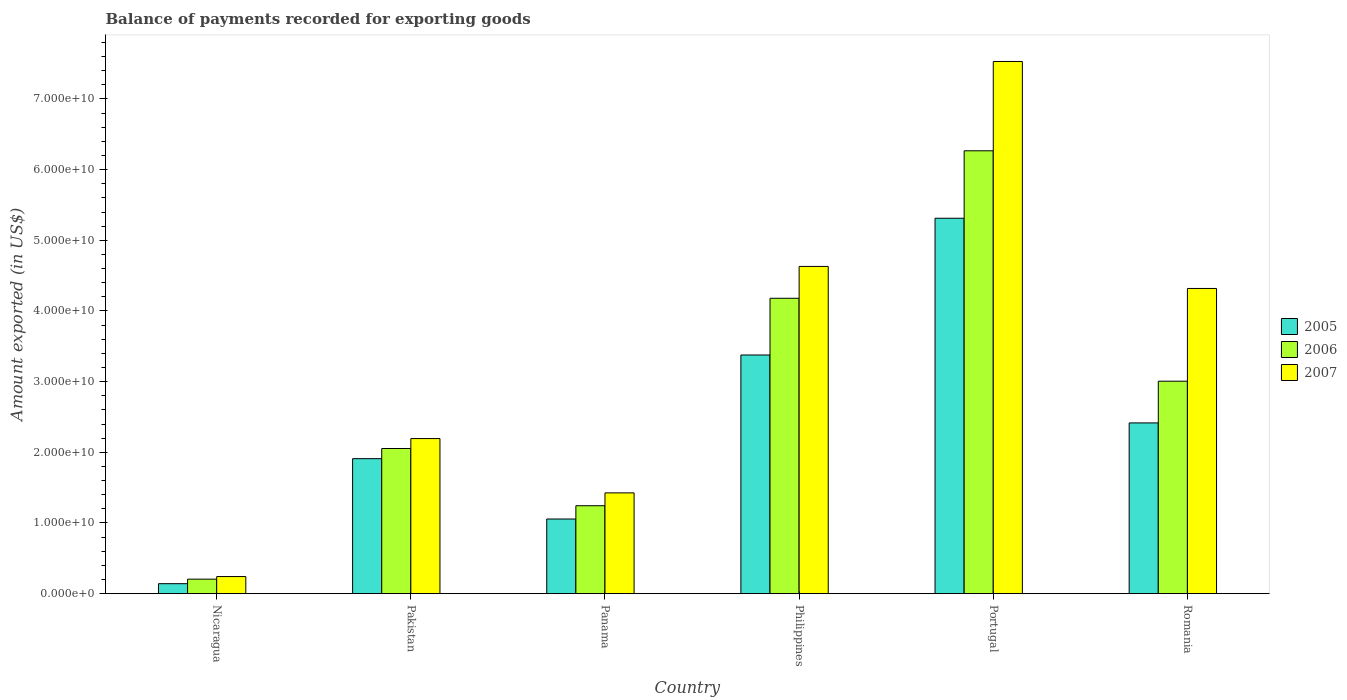How many different coloured bars are there?
Provide a succinct answer. 3. How many groups of bars are there?
Your answer should be very brief. 6. Are the number of bars per tick equal to the number of legend labels?
Provide a succinct answer. Yes. How many bars are there on the 4th tick from the left?
Your answer should be very brief. 3. How many bars are there on the 5th tick from the right?
Provide a succinct answer. 3. What is the label of the 2nd group of bars from the left?
Make the answer very short. Pakistan. In how many cases, is the number of bars for a given country not equal to the number of legend labels?
Your response must be concise. 0. What is the amount exported in 2005 in Pakistan?
Give a very brief answer. 1.91e+1. Across all countries, what is the maximum amount exported in 2005?
Your response must be concise. 5.31e+1. Across all countries, what is the minimum amount exported in 2005?
Your answer should be compact. 1.41e+09. In which country was the amount exported in 2007 minimum?
Your response must be concise. Nicaragua. What is the total amount exported in 2006 in the graph?
Give a very brief answer. 1.70e+11. What is the difference between the amount exported in 2005 in Portugal and that in Romania?
Your response must be concise. 2.90e+1. What is the difference between the amount exported in 2006 in Romania and the amount exported in 2005 in Nicaragua?
Keep it short and to the point. 2.87e+1. What is the average amount exported in 2006 per country?
Offer a terse response. 2.83e+1. What is the difference between the amount exported of/in 2007 and amount exported of/in 2006 in Portugal?
Your answer should be very brief. 1.26e+1. What is the ratio of the amount exported in 2005 in Panama to that in Portugal?
Ensure brevity in your answer.  0.2. Is the amount exported in 2006 in Pakistan less than that in Panama?
Provide a short and direct response. No. Is the difference between the amount exported in 2007 in Portugal and Romania greater than the difference between the amount exported in 2006 in Portugal and Romania?
Your response must be concise. No. What is the difference between the highest and the second highest amount exported in 2006?
Offer a terse response. 1.17e+1. What is the difference between the highest and the lowest amount exported in 2005?
Make the answer very short. 5.17e+1. In how many countries, is the amount exported in 2006 greater than the average amount exported in 2006 taken over all countries?
Give a very brief answer. 3. Is the sum of the amount exported in 2006 in Philippines and Romania greater than the maximum amount exported in 2005 across all countries?
Ensure brevity in your answer.  Yes. What does the 3rd bar from the right in Nicaragua represents?
Offer a very short reply. 2005. Is it the case that in every country, the sum of the amount exported in 2006 and amount exported in 2005 is greater than the amount exported in 2007?
Your response must be concise. Yes. How many countries are there in the graph?
Keep it short and to the point. 6. What is the difference between two consecutive major ticks on the Y-axis?
Your answer should be compact. 1.00e+1. Does the graph contain grids?
Provide a short and direct response. No. Where does the legend appear in the graph?
Your answer should be very brief. Center right. How many legend labels are there?
Ensure brevity in your answer.  3. What is the title of the graph?
Keep it short and to the point. Balance of payments recorded for exporting goods. What is the label or title of the X-axis?
Your answer should be compact. Country. What is the label or title of the Y-axis?
Give a very brief answer. Amount exported (in US$). What is the Amount exported (in US$) in 2005 in Nicaragua?
Provide a short and direct response. 1.41e+09. What is the Amount exported (in US$) in 2006 in Nicaragua?
Your answer should be compact. 2.05e+09. What is the Amount exported (in US$) in 2007 in Nicaragua?
Provide a succinct answer. 2.42e+09. What is the Amount exported (in US$) in 2005 in Pakistan?
Provide a short and direct response. 1.91e+1. What is the Amount exported (in US$) of 2006 in Pakistan?
Your response must be concise. 2.05e+1. What is the Amount exported (in US$) in 2007 in Pakistan?
Provide a short and direct response. 2.19e+1. What is the Amount exported (in US$) in 2005 in Panama?
Your answer should be compact. 1.06e+1. What is the Amount exported (in US$) of 2006 in Panama?
Offer a very short reply. 1.24e+1. What is the Amount exported (in US$) of 2007 in Panama?
Offer a terse response. 1.43e+1. What is the Amount exported (in US$) of 2005 in Philippines?
Keep it short and to the point. 3.38e+1. What is the Amount exported (in US$) in 2006 in Philippines?
Ensure brevity in your answer.  4.18e+1. What is the Amount exported (in US$) in 2007 in Philippines?
Your response must be concise. 4.63e+1. What is the Amount exported (in US$) in 2005 in Portugal?
Offer a terse response. 5.31e+1. What is the Amount exported (in US$) in 2006 in Portugal?
Make the answer very short. 6.27e+1. What is the Amount exported (in US$) in 2007 in Portugal?
Provide a succinct answer. 7.53e+1. What is the Amount exported (in US$) in 2005 in Romania?
Provide a succinct answer. 2.42e+1. What is the Amount exported (in US$) in 2006 in Romania?
Your response must be concise. 3.01e+1. What is the Amount exported (in US$) of 2007 in Romania?
Offer a very short reply. 4.32e+1. Across all countries, what is the maximum Amount exported (in US$) of 2005?
Provide a succinct answer. 5.31e+1. Across all countries, what is the maximum Amount exported (in US$) of 2006?
Provide a short and direct response. 6.27e+1. Across all countries, what is the maximum Amount exported (in US$) in 2007?
Give a very brief answer. 7.53e+1. Across all countries, what is the minimum Amount exported (in US$) in 2005?
Keep it short and to the point. 1.41e+09. Across all countries, what is the minimum Amount exported (in US$) of 2006?
Offer a very short reply. 2.05e+09. Across all countries, what is the minimum Amount exported (in US$) of 2007?
Give a very brief answer. 2.42e+09. What is the total Amount exported (in US$) of 2005 in the graph?
Your answer should be very brief. 1.42e+11. What is the total Amount exported (in US$) in 2006 in the graph?
Provide a succinct answer. 1.70e+11. What is the total Amount exported (in US$) in 2007 in the graph?
Give a very brief answer. 2.03e+11. What is the difference between the Amount exported (in US$) in 2005 in Nicaragua and that in Pakistan?
Offer a terse response. -1.77e+1. What is the difference between the Amount exported (in US$) of 2006 in Nicaragua and that in Pakistan?
Ensure brevity in your answer.  -1.85e+1. What is the difference between the Amount exported (in US$) in 2007 in Nicaragua and that in Pakistan?
Provide a succinct answer. -1.95e+1. What is the difference between the Amount exported (in US$) of 2005 in Nicaragua and that in Panama?
Make the answer very short. -9.15e+09. What is the difference between the Amount exported (in US$) in 2006 in Nicaragua and that in Panama?
Keep it short and to the point. -1.04e+1. What is the difference between the Amount exported (in US$) of 2007 in Nicaragua and that in Panama?
Keep it short and to the point. -1.18e+1. What is the difference between the Amount exported (in US$) in 2005 in Nicaragua and that in Philippines?
Your answer should be compact. -3.24e+1. What is the difference between the Amount exported (in US$) in 2006 in Nicaragua and that in Philippines?
Provide a short and direct response. -3.97e+1. What is the difference between the Amount exported (in US$) of 2007 in Nicaragua and that in Philippines?
Ensure brevity in your answer.  -4.39e+1. What is the difference between the Amount exported (in US$) in 2005 in Nicaragua and that in Portugal?
Offer a terse response. -5.17e+1. What is the difference between the Amount exported (in US$) of 2006 in Nicaragua and that in Portugal?
Provide a short and direct response. -6.06e+1. What is the difference between the Amount exported (in US$) of 2007 in Nicaragua and that in Portugal?
Keep it short and to the point. -7.29e+1. What is the difference between the Amount exported (in US$) in 2005 in Nicaragua and that in Romania?
Your answer should be very brief. -2.27e+1. What is the difference between the Amount exported (in US$) of 2006 in Nicaragua and that in Romania?
Offer a very short reply. -2.80e+1. What is the difference between the Amount exported (in US$) in 2007 in Nicaragua and that in Romania?
Offer a terse response. -4.08e+1. What is the difference between the Amount exported (in US$) in 2005 in Pakistan and that in Panama?
Keep it short and to the point. 8.54e+09. What is the difference between the Amount exported (in US$) in 2006 in Pakistan and that in Panama?
Your answer should be compact. 8.10e+09. What is the difference between the Amount exported (in US$) of 2007 in Pakistan and that in Panama?
Offer a terse response. 7.69e+09. What is the difference between the Amount exported (in US$) in 2005 in Pakistan and that in Philippines?
Give a very brief answer. -1.47e+1. What is the difference between the Amount exported (in US$) in 2006 in Pakistan and that in Philippines?
Make the answer very short. -2.13e+1. What is the difference between the Amount exported (in US$) of 2007 in Pakistan and that in Philippines?
Provide a succinct answer. -2.44e+1. What is the difference between the Amount exported (in US$) in 2005 in Pakistan and that in Portugal?
Ensure brevity in your answer.  -3.40e+1. What is the difference between the Amount exported (in US$) in 2006 in Pakistan and that in Portugal?
Provide a succinct answer. -4.21e+1. What is the difference between the Amount exported (in US$) of 2007 in Pakistan and that in Portugal?
Offer a very short reply. -5.34e+1. What is the difference between the Amount exported (in US$) in 2005 in Pakistan and that in Romania?
Give a very brief answer. -5.06e+09. What is the difference between the Amount exported (in US$) in 2006 in Pakistan and that in Romania?
Provide a succinct answer. -9.52e+09. What is the difference between the Amount exported (in US$) of 2007 in Pakistan and that in Romania?
Offer a terse response. -2.12e+1. What is the difference between the Amount exported (in US$) in 2005 in Panama and that in Philippines?
Offer a terse response. -2.32e+1. What is the difference between the Amount exported (in US$) in 2006 in Panama and that in Philippines?
Offer a terse response. -2.94e+1. What is the difference between the Amount exported (in US$) in 2007 in Panama and that in Philippines?
Ensure brevity in your answer.  -3.20e+1. What is the difference between the Amount exported (in US$) in 2005 in Panama and that in Portugal?
Make the answer very short. -4.26e+1. What is the difference between the Amount exported (in US$) in 2006 in Panama and that in Portugal?
Your response must be concise. -5.02e+1. What is the difference between the Amount exported (in US$) of 2007 in Panama and that in Portugal?
Make the answer very short. -6.10e+1. What is the difference between the Amount exported (in US$) in 2005 in Panama and that in Romania?
Your answer should be very brief. -1.36e+1. What is the difference between the Amount exported (in US$) of 2006 in Panama and that in Romania?
Your response must be concise. -1.76e+1. What is the difference between the Amount exported (in US$) of 2007 in Panama and that in Romania?
Your answer should be very brief. -2.89e+1. What is the difference between the Amount exported (in US$) in 2005 in Philippines and that in Portugal?
Offer a terse response. -1.94e+1. What is the difference between the Amount exported (in US$) of 2006 in Philippines and that in Portugal?
Your response must be concise. -2.09e+1. What is the difference between the Amount exported (in US$) in 2007 in Philippines and that in Portugal?
Your response must be concise. -2.90e+1. What is the difference between the Amount exported (in US$) of 2005 in Philippines and that in Romania?
Your answer should be very brief. 9.61e+09. What is the difference between the Amount exported (in US$) of 2006 in Philippines and that in Romania?
Ensure brevity in your answer.  1.17e+1. What is the difference between the Amount exported (in US$) of 2007 in Philippines and that in Romania?
Make the answer very short. 3.12e+09. What is the difference between the Amount exported (in US$) in 2005 in Portugal and that in Romania?
Keep it short and to the point. 2.90e+1. What is the difference between the Amount exported (in US$) in 2006 in Portugal and that in Romania?
Give a very brief answer. 3.26e+1. What is the difference between the Amount exported (in US$) in 2007 in Portugal and that in Romania?
Keep it short and to the point. 3.21e+1. What is the difference between the Amount exported (in US$) in 2005 in Nicaragua and the Amount exported (in US$) in 2006 in Pakistan?
Provide a short and direct response. -1.91e+1. What is the difference between the Amount exported (in US$) in 2005 in Nicaragua and the Amount exported (in US$) in 2007 in Pakistan?
Your answer should be compact. -2.05e+1. What is the difference between the Amount exported (in US$) of 2006 in Nicaragua and the Amount exported (in US$) of 2007 in Pakistan?
Give a very brief answer. -1.99e+1. What is the difference between the Amount exported (in US$) of 2005 in Nicaragua and the Amount exported (in US$) of 2006 in Panama?
Offer a terse response. -1.10e+1. What is the difference between the Amount exported (in US$) of 2005 in Nicaragua and the Amount exported (in US$) of 2007 in Panama?
Keep it short and to the point. -1.28e+1. What is the difference between the Amount exported (in US$) in 2006 in Nicaragua and the Amount exported (in US$) in 2007 in Panama?
Ensure brevity in your answer.  -1.22e+1. What is the difference between the Amount exported (in US$) of 2005 in Nicaragua and the Amount exported (in US$) of 2006 in Philippines?
Offer a very short reply. -4.04e+1. What is the difference between the Amount exported (in US$) of 2005 in Nicaragua and the Amount exported (in US$) of 2007 in Philippines?
Your response must be concise. -4.49e+1. What is the difference between the Amount exported (in US$) of 2006 in Nicaragua and the Amount exported (in US$) of 2007 in Philippines?
Make the answer very short. -4.43e+1. What is the difference between the Amount exported (in US$) of 2005 in Nicaragua and the Amount exported (in US$) of 2006 in Portugal?
Offer a very short reply. -6.13e+1. What is the difference between the Amount exported (in US$) in 2005 in Nicaragua and the Amount exported (in US$) in 2007 in Portugal?
Provide a succinct answer. -7.39e+1. What is the difference between the Amount exported (in US$) in 2006 in Nicaragua and the Amount exported (in US$) in 2007 in Portugal?
Provide a short and direct response. -7.33e+1. What is the difference between the Amount exported (in US$) in 2005 in Nicaragua and the Amount exported (in US$) in 2006 in Romania?
Provide a short and direct response. -2.87e+1. What is the difference between the Amount exported (in US$) of 2005 in Nicaragua and the Amount exported (in US$) of 2007 in Romania?
Offer a very short reply. -4.18e+1. What is the difference between the Amount exported (in US$) of 2006 in Nicaragua and the Amount exported (in US$) of 2007 in Romania?
Ensure brevity in your answer.  -4.11e+1. What is the difference between the Amount exported (in US$) in 2005 in Pakistan and the Amount exported (in US$) in 2006 in Panama?
Your response must be concise. 6.66e+09. What is the difference between the Amount exported (in US$) in 2005 in Pakistan and the Amount exported (in US$) in 2007 in Panama?
Make the answer very short. 4.84e+09. What is the difference between the Amount exported (in US$) in 2006 in Pakistan and the Amount exported (in US$) in 2007 in Panama?
Your answer should be compact. 6.28e+09. What is the difference between the Amount exported (in US$) of 2005 in Pakistan and the Amount exported (in US$) of 2006 in Philippines?
Offer a terse response. -2.27e+1. What is the difference between the Amount exported (in US$) of 2005 in Pakistan and the Amount exported (in US$) of 2007 in Philippines?
Your response must be concise. -2.72e+1. What is the difference between the Amount exported (in US$) in 2006 in Pakistan and the Amount exported (in US$) in 2007 in Philippines?
Make the answer very short. -2.58e+1. What is the difference between the Amount exported (in US$) of 2005 in Pakistan and the Amount exported (in US$) of 2006 in Portugal?
Offer a terse response. -4.36e+1. What is the difference between the Amount exported (in US$) in 2005 in Pakistan and the Amount exported (in US$) in 2007 in Portugal?
Your answer should be compact. -5.62e+1. What is the difference between the Amount exported (in US$) of 2006 in Pakistan and the Amount exported (in US$) of 2007 in Portugal?
Give a very brief answer. -5.48e+1. What is the difference between the Amount exported (in US$) of 2005 in Pakistan and the Amount exported (in US$) of 2006 in Romania?
Offer a terse response. -1.10e+1. What is the difference between the Amount exported (in US$) in 2005 in Pakistan and the Amount exported (in US$) in 2007 in Romania?
Provide a short and direct response. -2.41e+1. What is the difference between the Amount exported (in US$) of 2006 in Pakistan and the Amount exported (in US$) of 2007 in Romania?
Your answer should be very brief. -2.26e+1. What is the difference between the Amount exported (in US$) of 2005 in Panama and the Amount exported (in US$) of 2006 in Philippines?
Offer a very short reply. -3.12e+1. What is the difference between the Amount exported (in US$) in 2005 in Panama and the Amount exported (in US$) in 2007 in Philippines?
Make the answer very short. -3.57e+1. What is the difference between the Amount exported (in US$) in 2006 in Panama and the Amount exported (in US$) in 2007 in Philippines?
Provide a succinct answer. -3.39e+1. What is the difference between the Amount exported (in US$) of 2005 in Panama and the Amount exported (in US$) of 2006 in Portugal?
Make the answer very short. -5.21e+1. What is the difference between the Amount exported (in US$) of 2005 in Panama and the Amount exported (in US$) of 2007 in Portugal?
Keep it short and to the point. -6.47e+1. What is the difference between the Amount exported (in US$) in 2006 in Panama and the Amount exported (in US$) in 2007 in Portugal?
Your answer should be very brief. -6.29e+1. What is the difference between the Amount exported (in US$) in 2005 in Panama and the Amount exported (in US$) in 2006 in Romania?
Ensure brevity in your answer.  -1.95e+1. What is the difference between the Amount exported (in US$) in 2005 in Panama and the Amount exported (in US$) in 2007 in Romania?
Provide a short and direct response. -3.26e+1. What is the difference between the Amount exported (in US$) in 2006 in Panama and the Amount exported (in US$) in 2007 in Romania?
Your answer should be very brief. -3.07e+1. What is the difference between the Amount exported (in US$) of 2005 in Philippines and the Amount exported (in US$) of 2006 in Portugal?
Keep it short and to the point. -2.89e+1. What is the difference between the Amount exported (in US$) of 2005 in Philippines and the Amount exported (in US$) of 2007 in Portugal?
Keep it short and to the point. -4.15e+1. What is the difference between the Amount exported (in US$) in 2006 in Philippines and the Amount exported (in US$) in 2007 in Portugal?
Your answer should be compact. -3.35e+1. What is the difference between the Amount exported (in US$) of 2005 in Philippines and the Amount exported (in US$) of 2006 in Romania?
Your answer should be very brief. 3.71e+09. What is the difference between the Amount exported (in US$) of 2005 in Philippines and the Amount exported (in US$) of 2007 in Romania?
Ensure brevity in your answer.  -9.42e+09. What is the difference between the Amount exported (in US$) of 2006 in Philippines and the Amount exported (in US$) of 2007 in Romania?
Offer a terse response. -1.39e+09. What is the difference between the Amount exported (in US$) in 2005 in Portugal and the Amount exported (in US$) in 2006 in Romania?
Offer a very short reply. 2.31e+1. What is the difference between the Amount exported (in US$) of 2005 in Portugal and the Amount exported (in US$) of 2007 in Romania?
Ensure brevity in your answer.  9.94e+09. What is the difference between the Amount exported (in US$) of 2006 in Portugal and the Amount exported (in US$) of 2007 in Romania?
Your answer should be compact. 1.95e+1. What is the average Amount exported (in US$) of 2005 per country?
Ensure brevity in your answer.  2.37e+1. What is the average Amount exported (in US$) in 2006 per country?
Your response must be concise. 2.83e+1. What is the average Amount exported (in US$) of 2007 per country?
Your answer should be very brief. 3.39e+1. What is the difference between the Amount exported (in US$) of 2005 and Amount exported (in US$) of 2006 in Nicaragua?
Your response must be concise. -6.43e+08. What is the difference between the Amount exported (in US$) in 2005 and Amount exported (in US$) in 2007 in Nicaragua?
Make the answer very short. -1.01e+09. What is the difference between the Amount exported (in US$) of 2006 and Amount exported (in US$) of 2007 in Nicaragua?
Ensure brevity in your answer.  -3.66e+08. What is the difference between the Amount exported (in US$) in 2005 and Amount exported (in US$) in 2006 in Pakistan?
Provide a succinct answer. -1.44e+09. What is the difference between the Amount exported (in US$) of 2005 and Amount exported (in US$) of 2007 in Pakistan?
Ensure brevity in your answer.  -2.84e+09. What is the difference between the Amount exported (in US$) of 2006 and Amount exported (in US$) of 2007 in Pakistan?
Your response must be concise. -1.41e+09. What is the difference between the Amount exported (in US$) of 2005 and Amount exported (in US$) of 2006 in Panama?
Make the answer very short. -1.88e+09. What is the difference between the Amount exported (in US$) of 2005 and Amount exported (in US$) of 2007 in Panama?
Make the answer very short. -3.70e+09. What is the difference between the Amount exported (in US$) in 2006 and Amount exported (in US$) in 2007 in Panama?
Offer a very short reply. -1.82e+09. What is the difference between the Amount exported (in US$) in 2005 and Amount exported (in US$) in 2006 in Philippines?
Ensure brevity in your answer.  -8.03e+09. What is the difference between the Amount exported (in US$) in 2005 and Amount exported (in US$) in 2007 in Philippines?
Ensure brevity in your answer.  -1.25e+1. What is the difference between the Amount exported (in US$) of 2006 and Amount exported (in US$) of 2007 in Philippines?
Make the answer very short. -4.51e+09. What is the difference between the Amount exported (in US$) in 2005 and Amount exported (in US$) in 2006 in Portugal?
Offer a terse response. -9.54e+09. What is the difference between the Amount exported (in US$) in 2005 and Amount exported (in US$) in 2007 in Portugal?
Keep it short and to the point. -2.22e+1. What is the difference between the Amount exported (in US$) in 2006 and Amount exported (in US$) in 2007 in Portugal?
Provide a succinct answer. -1.26e+1. What is the difference between the Amount exported (in US$) of 2005 and Amount exported (in US$) of 2006 in Romania?
Provide a succinct answer. -5.90e+09. What is the difference between the Amount exported (in US$) in 2005 and Amount exported (in US$) in 2007 in Romania?
Offer a very short reply. -1.90e+1. What is the difference between the Amount exported (in US$) in 2006 and Amount exported (in US$) in 2007 in Romania?
Keep it short and to the point. -1.31e+1. What is the ratio of the Amount exported (in US$) of 2005 in Nicaragua to that in Pakistan?
Your answer should be very brief. 0.07. What is the ratio of the Amount exported (in US$) of 2006 in Nicaragua to that in Pakistan?
Keep it short and to the point. 0.1. What is the ratio of the Amount exported (in US$) of 2007 in Nicaragua to that in Pakistan?
Your answer should be very brief. 0.11. What is the ratio of the Amount exported (in US$) in 2005 in Nicaragua to that in Panama?
Ensure brevity in your answer.  0.13. What is the ratio of the Amount exported (in US$) in 2006 in Nicaragua to that in Panama?
Make the answer very short. 0.17. What is the ratio of the Amount exported (in US$) in 2007 in Nicaragua to that in Panama?
Provide a succinct answer. 0.17. What is the ratio of the Amount exported (in US$) in 2005 in Nicaragua to that in Philippines?
Provide a succinct answer. 0.04. What is the ratio of the Amount exported (in US$) of 2006 in Nicaragua to that in Philippines?
Ensure brevity in your answer.  0.05. What is the ratio of the Amount exported (in US$) in 2007 in Nicaragua to that in Philippines?
Provide a succinct answer. 0.05. What is the ratio of the Amount exported (in US$) of 2005 in Nicaragua to that in Portugal?
Your answer should be compact. 0.03. What is the ratio of the Amount exported (in US$) in 2006 in Nicaragua to that in Portugal?
Offer a terse response. 0.03. What is the ratio of the Amount exported (in US$) in 2007 in Nicaragua to that in Portugal?
Your response must be concise. 0.03. What is the ratio of the Amount exported (in US$) in 2005 in Nicaragua to that in Romania?
Your answer should be very brief. 0.06. What is the ratio of the Amount exported (in US$) in 2006 in Nicaragua to that in Romania?
Provide a succinct answer. 0.07. What is the ratio of the Amount exported (in US$) of 2007 in Nicaragua to that in Romania?
Your answer should be very brief. 0.06. What is the ratio of the Amount exported (in US$) of 2005 in Pakistan to that in Panama?
Keep it short and to the point. 1.81. What is the ratio of the Amount exported (in US$) of 2006 in Pakistan to that in Panama?
Offer a very short reply. 1.65. What is the ratio of the Amount exported (in US$) of 2007 in Pakistan to that in Panama?
Give a very brief answer. 1.54. What is the ratio of the Amount exported (in US$) in 2005 in Pakistan to that in Philippines?
Offer a terse response. 0.57. What is the ratio of the Amount exported (in US$) in 2006 in Pakistan to that in Philippines?
Provide a succinct answer. 0.49. What is the ratio of the Amount exported (in US$) in 2007 in Pakistan to that in Philippines?
Your answer should be very brief. 0.47. What is the ratio of the Amount exported (in US$) in 2005 in Pakistan to that in Portugal?
Your response must be concise. 0.36. What is the ratio of the Amount exported (in US$) in 2006 in Pakistan to that in Portugal?
Your answer should be very brief. 0.33. What is the ratio of the Amount exported (in US$) of 2007 in Pakistan to that in Portugal?
Offer a terse response. 0.29. What is the ratio of the Amount exported (in US$) of 2005 in Pakistan to that in Romania?
Keep it short and to the point. 0.79. What is the ratio of the Amount exported (in US$) in 2006 in Pakistan to that in Romania?
Your response must be concise. 0.68. What is the ratio of the Amount exported (in US$) of 2007 in Pakistan to that in Romania?
Provide a short and direct response. 0.51. What is the ratio of the Amount exported (in US$) in 2005 in Panama to that in Philippines?
Provide a succinct answer. 0.31. What is the ratio of the Amount exported (in US$) in 2006 in Panama to that in Philippines?
Provide a short and direct response. 0.3. What is the ratio of the Amount exported (in US$) of 2007 in Panama to that in Philippines?
Provide a short and direct response. 0.31. What is the ratio of the Amount exported (in US$) in 2005 in Panama to that in Portugal?
Ensure brevity in your answer.  0.2. What is the ratio of the Amount exported (in US$) in 2006 in Panama to that in Portugal?
Ensure brevity in your answer.  0.2. What is the ratio of the Amount exported (in US$) in 2007 in Panama to that in Portugal?
Offer a very short reply. 0.19. What is the ratio of the Amount exported (in US$) of 2005 in Panama to that in Romania?
Your answer should be very brief. 0.44. What is the ratio of the Amount exported (in US$) of 2006 in Panama to that in Romania?
Provide a succinct answer. 0.41. What is the ratio of the Amount exported (in US$) in 2007 in Panama to that in Romania?
Keep it short and to the point. 0.33. What is the ratio of the Amount exported (in US$) in 2005 in Philippines to that in Portugal?
Give a very brief answer. 0.64. What is the ratio of the Amount exported (in US$) of 2006 in Philippines to that in Portugal?
Ensure brevity in your answer.  0.67. What is the ratio of the Amount exported (in US$) in 2007 in Philippines to that in Portugal?
Your answer should be very brief. 0.61. What is the ratio of the Amount exported (in US$) in 2005 in Philippines to that in Romania?
Your response must be concise. 1.4. What is the ratio of the Amount exported (in US$) of 2006 in Philippines to that in Romania?
Ensure brevity in your answer.  1.39. What is the ratio of the Amount exported (in US$) in 2007 in Philippines to that in Romania?
Provide a succinct answer. 1.07. What is the ratio of the Amount exported (in US$) in 2005 in Portugal to that in Romania?
Your response must be concise. 2.2. What is the ratio of the Amount exported (in US$) of 2006 in Portugal to that in Romania?
Keep it short and to the point. 2.08. What is the ratio of the Amount exported (in US$) of 2007 in Portugal to that in Romania?
Your response must be concise. 1.74. What is the difference between the highest and the second highest Amount exported (in US$) of 2005?
Ensure brevity in your answer.  1.94e+1. What is the difference between the highest and the second highest Amount exported (in US$) in 2006?
Offer a terse response. 2.09e+1. What is the difference between the highest and the second highest Amount exported (in US$) in 2007?
Provide a succinct answer. 2.90e+1. What is the difference between the highest and the lowest Amount exported (in US$) of 2005?
Make the answer very short. 5.17e+1. What is the difference between the highest and the lowest Amount exported (in US$) in 2006?
Make the answer very short. 6.06e+1. What is the difference between the highest and the lowest Amount exported (in US$) in 2007?
Offer a very short reply. 7.29e+1. 